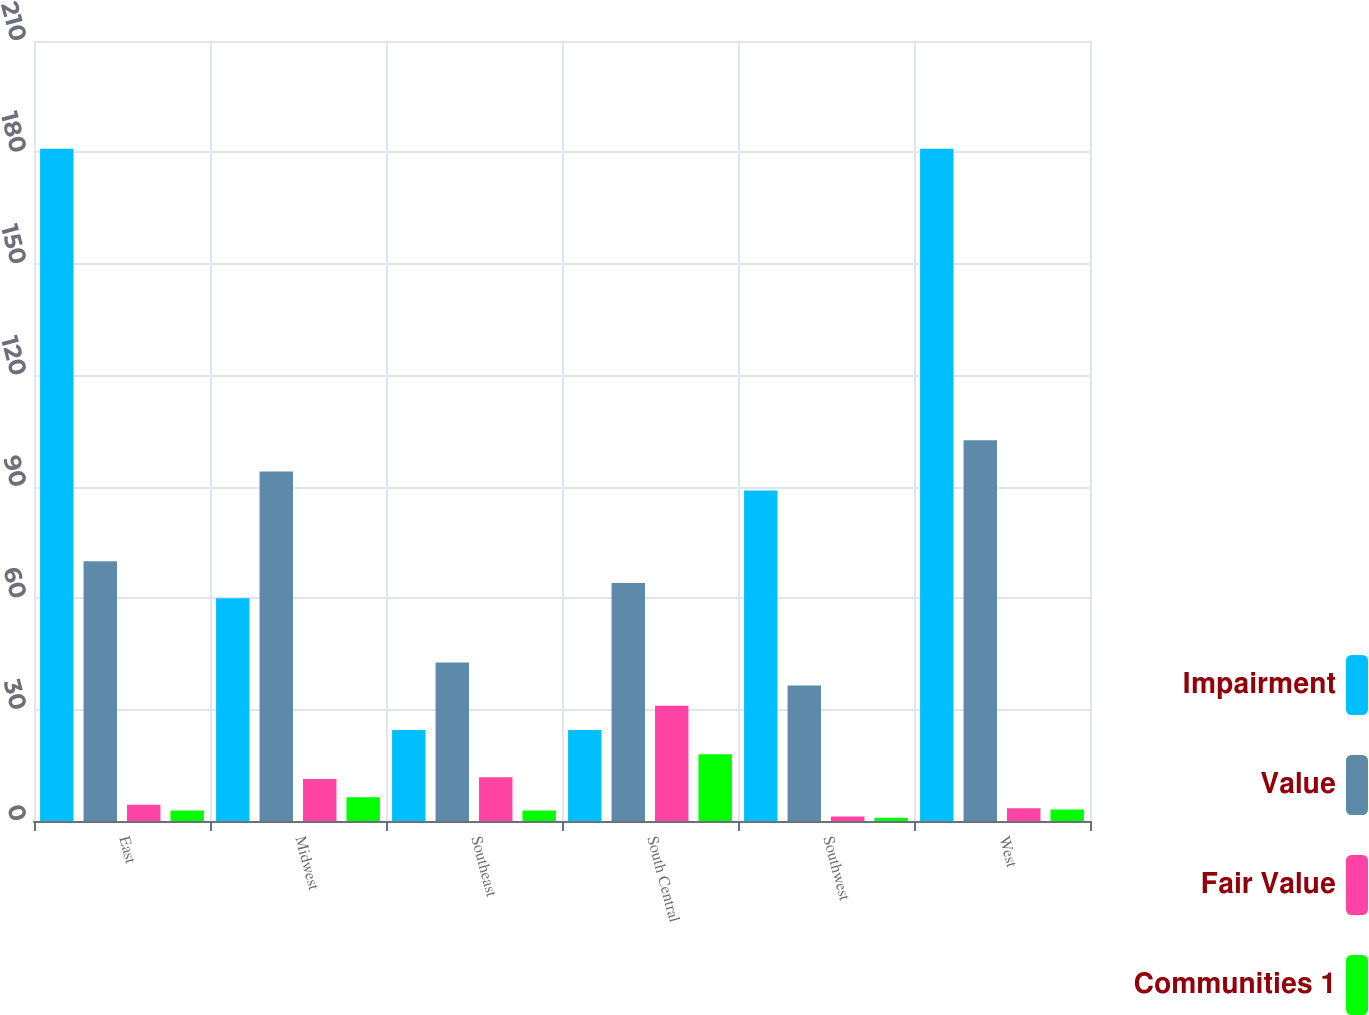<chart> <loc_0><loc_0><loc_500><loc_500><stacked_bar_chart><ecel><fcel>East<fcel>Midwest<fcel>Southeast<fcel>South Central<fcel>Southwest<fcel>West<nl><fcel>Impairment<fcel>181<fcel>60<fcel>24.5<fcel>24.5<fcel>89<fcel>181<nl><fcel>Value<fcel>69.9<fcel>94.1<fcel>42.7<fcel>64.1<fcel>36.5<fcel>102.5<nl><fcel>Fair Value<fcel>4.4<fcel>11.3<fcel>11.8<fcel>31<fcel>1.2<fcel>3.4<nl><fcel>Communities 1<fcel>2.8<fcel>6.4<fcel>2.8<fcel>18<fcel>0.9<fcel>3.1<nl></chart> 